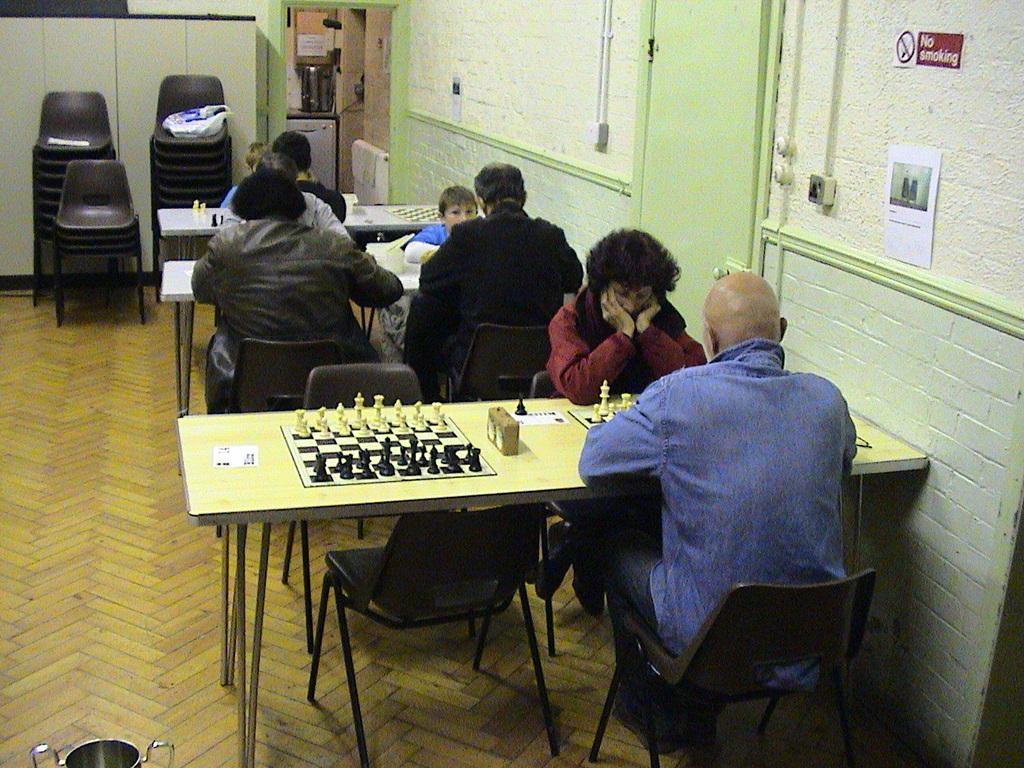Please provide a concise description of this image. In this image, group of people are sat on the black color chair. We can see 3 tables. On top of table, few items are placed. On right side, we can see white and green color wall and door where, there is a sticker on it. There is a sign board. On top of the image, we can see machine's ,some box, containers. Here few chairs and yellow color ,container. 